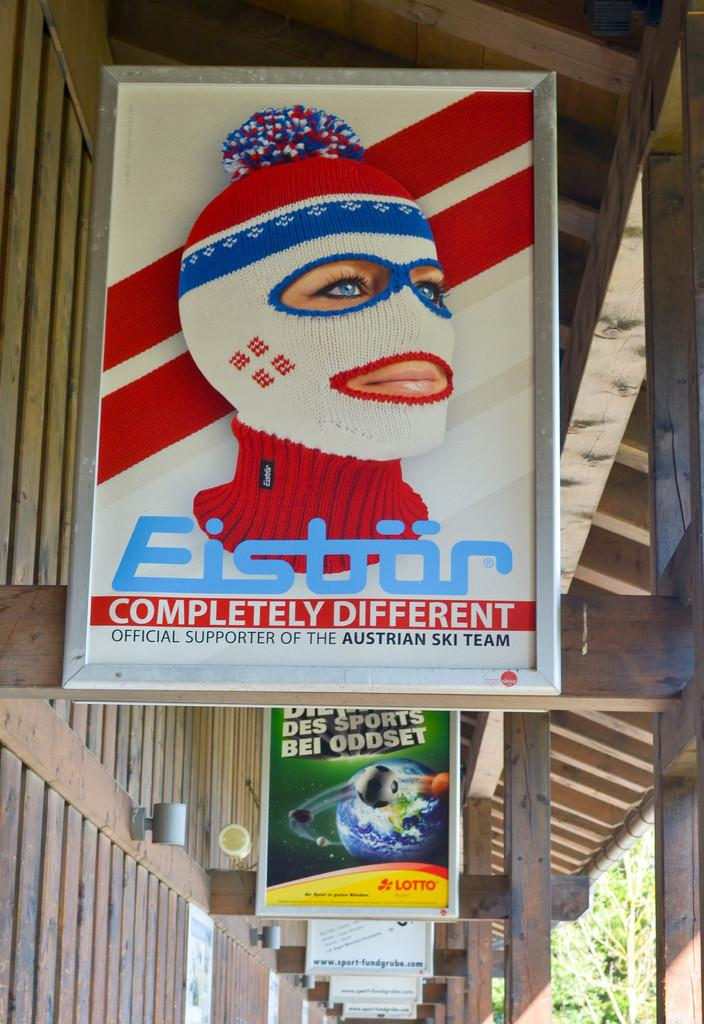<image>
Summarize the visual content of the image. An unusual poster with a girl in a ski mask and the line official supporter of the Austrian ski team. 